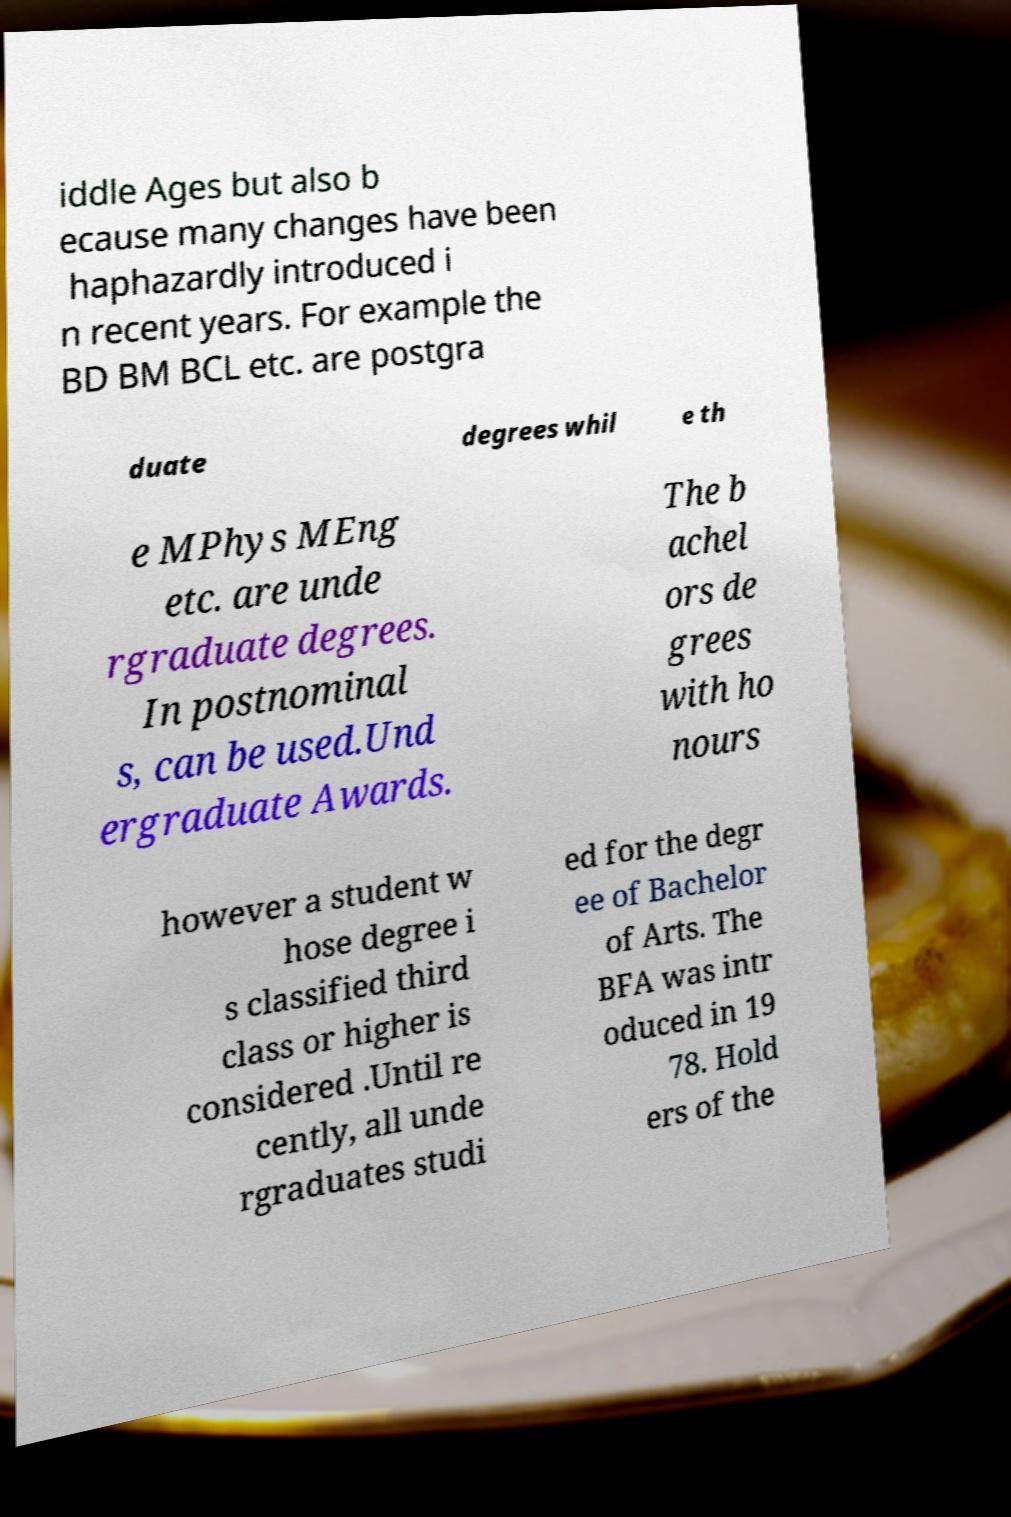I need the written content from this picture converted into text. Can you do that? iddle Ages but also b ecause many changes have been haphazardly introduced i n recent years. For example the BD BM BCL etc. are postgra duate degrees whil e th e MPhys MEng etc. are unde rgraduate degrees. In postnominal s, can be used.Und ergraduate Awards. The b achel ors de grees with ho nours however a student w hose degree i s classified third class or higher is considered .Until re cently, all unde rgraduates studi ed for the degr ee of Bachelor of Arts. The BFA was intr oduced in 19 78. Hold ers of the 